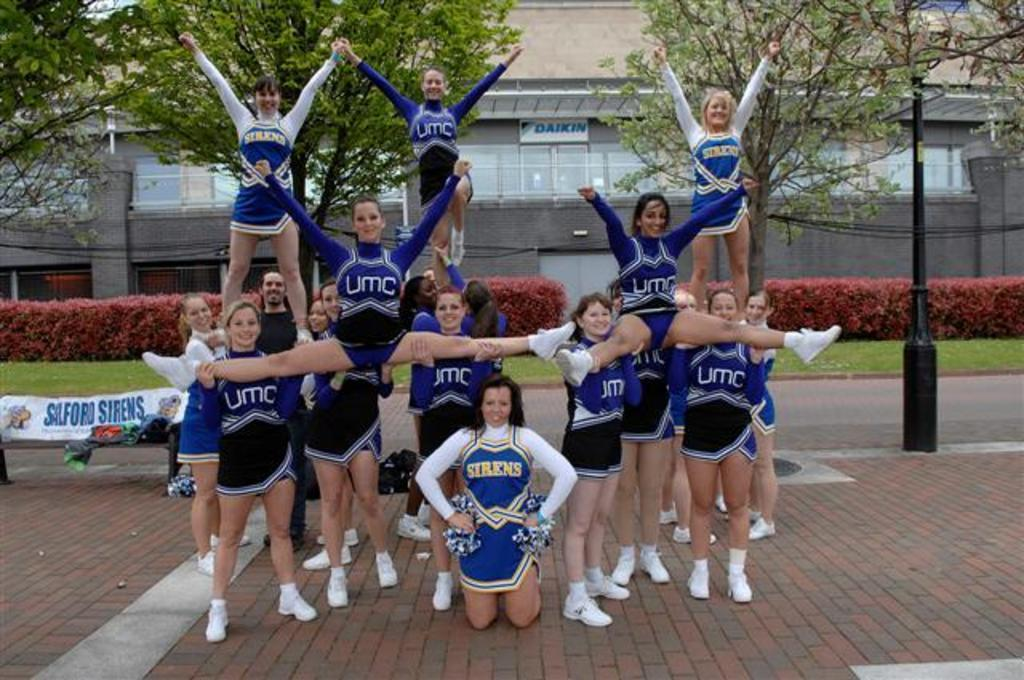<image>
Share a concise interpretation of the image provided. Sirens and UMC cheerleaders are in a pyramid pose. 